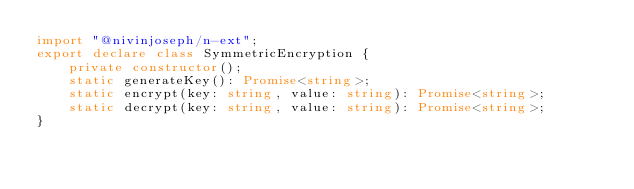Convert code to text. <code><loc_0><loc_0><loc_500><loc_500><_TypeScript_>import "@nivinjoseph/n-ext";
export declare class SymmetricEncryption {
    private constructor();
    static generateKey(): Promise<string>;
    static encrypt(key: string, value: string): Promise<string>;
    static decrypt(key: string, value: string): Promise<string>;
}
</code> 